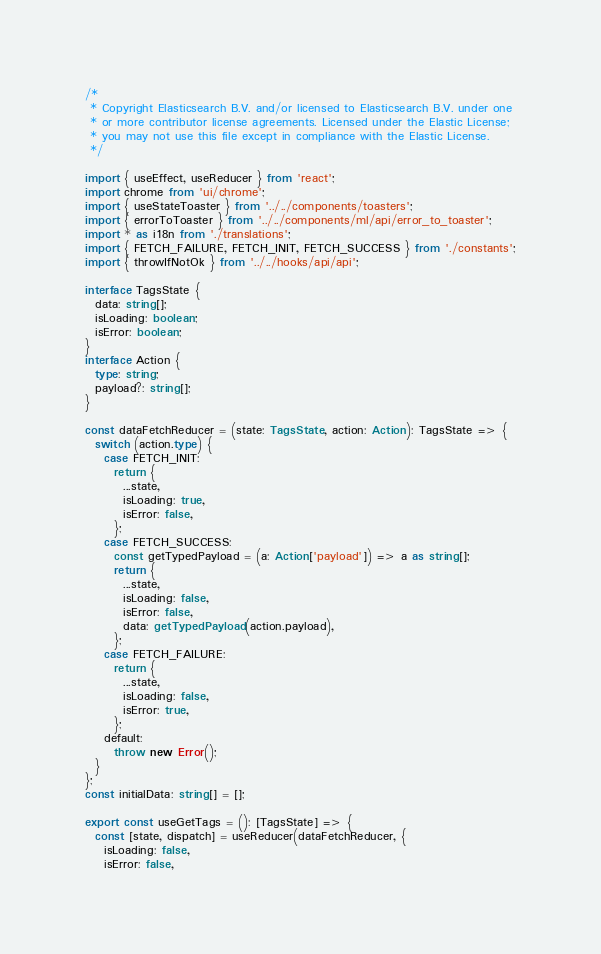Convert code to text. <code><loc_0><loc_0><loc_500><loc_500><_TypeScript_>/*
 * Copyright Elasticsearch B.V. and/or licensed to Elasticsearch B.V. under one
 * or more contributor license agreements. Licensed under the Elastic License;
 * you may not use this file except in compliance with the Elastic License.
 */

import { useEffect, useReducer } from 'react';
import chrome from 'ui/chrome';
import { useStateToaster } from '../../components/toasters';
import { errorToToaster } from '../../components/ml/api/error_to_toaster';
import * as i18n from './translations';
import { FETCH_FAILURE, FETCH_INIT, FETCH_SUCCESS } from './constants';
import { throwIfNotOk } from '../../hooks/api/api';

interface TagsState {
  data: string[];
  isLoading: boolean;
  isError: boolean;
}
interface Action {
  type: string;
  payload?: string[];
}

const dataFetchReducer = (state: TagsState, action: Action): TagsState => {
  switch (action.type) {
    case FETCH_INIT:
      return {
        ...state,
        isLoading: true,
        isError: false,
      };
    case FETCH_SUCCESS:
      const getTypedPayload = (a: Action['payload']) => a as string[];
      return {
        ...state,
        isLoading: false,
        isError: false,
        data: getTypedPayload(action.payload),
      };
    case FETCH_FAILURE:
      return {
        ...state,
        isLoading: false,
        isError: true,
      };
    default:
      throw new Error();
  }
};
const initialData: string[] = [];

export const useGetTags = (): [TagsState] => {
  const [state, dispatch] = useReducer(dataFetchReducer, {
    isLoading: false,
    isError: false,</code> 